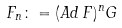<formula> <loc_0><loc_0><loc_500><loc_500>F _ { n } \colon = ( A d \, F ) ^ { n } G</formula> 